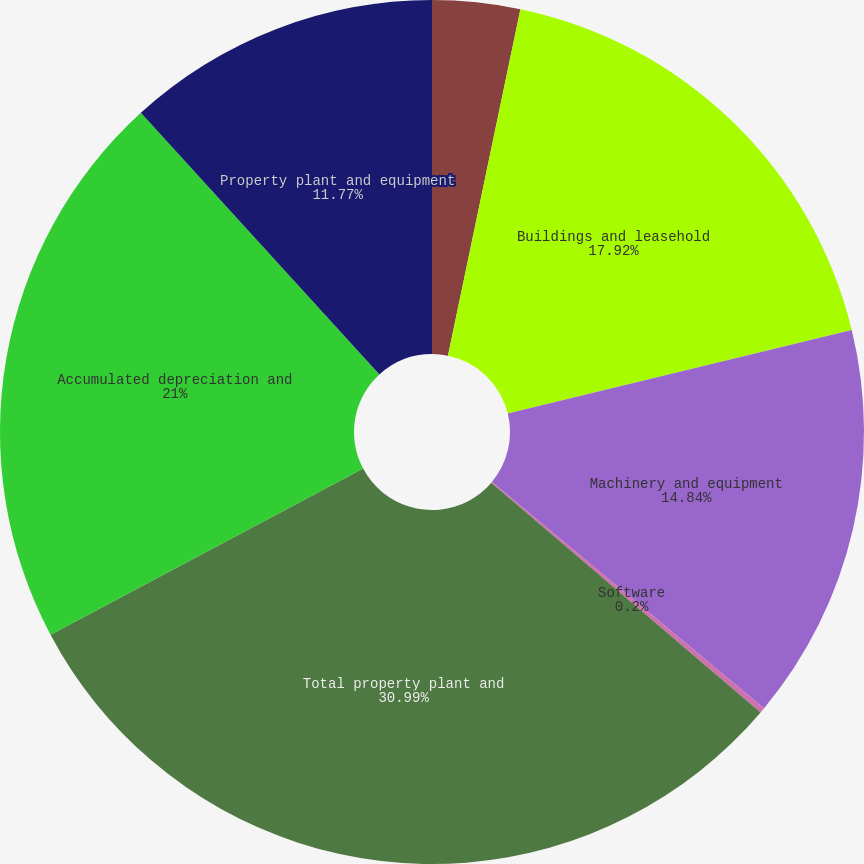Convert chart. <chart><loc_0><loc_0><loc_500><loc_500><pie_chart><fcel>Land<fcel>Buildings and leasehold<fcel>Machinery and equipment<fcel>Software<fcel>Total property plant and<fcel>Accumulated depreciation and<fcel>Property plant and equipment<nl><fcel>3.28%<fcel>17.92%<fcel>14.84%<fcel>0.2%<fcel>30.98%<fcel>21.0%<fcel>11.77%<nl></chart> 